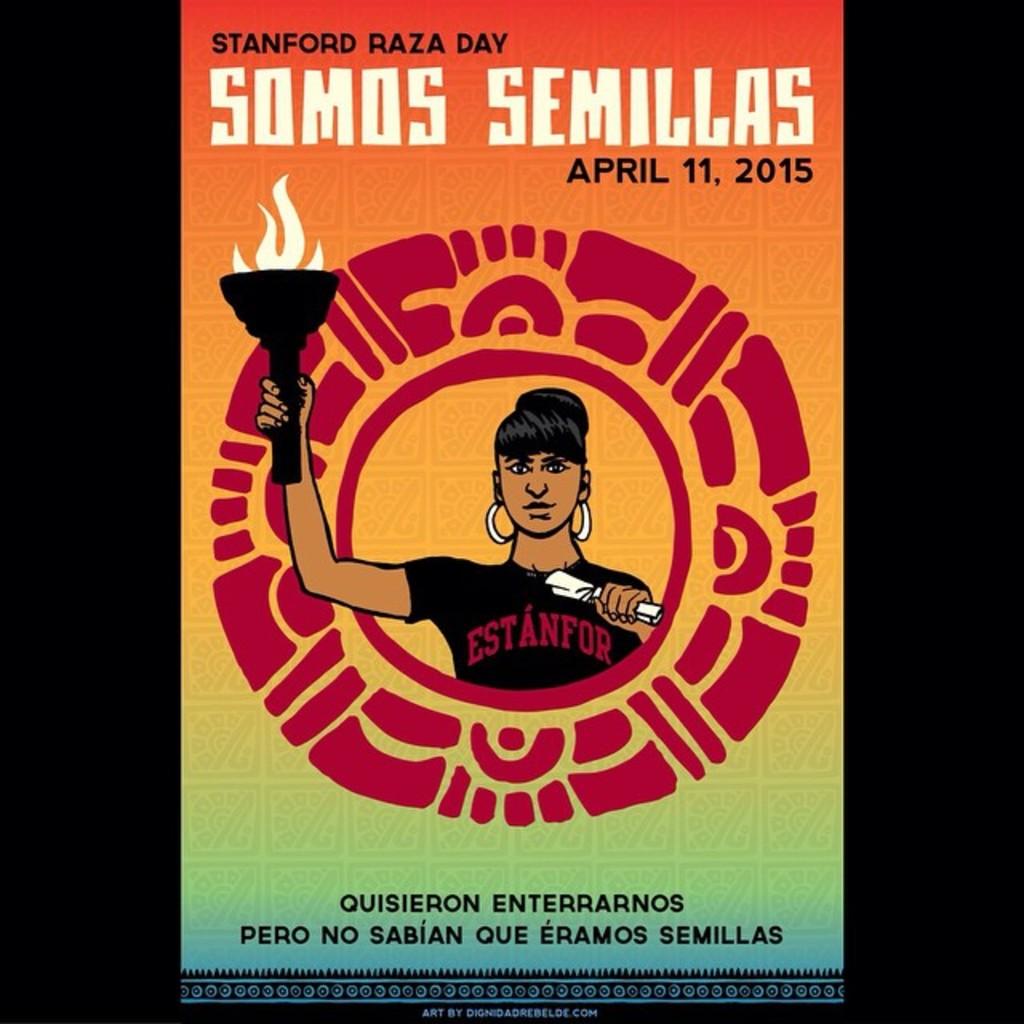What is the name of the book?
Give a very brief answer. Somos semillas. What day is the event?
Keep it short and to the point. April 11, 2015. 